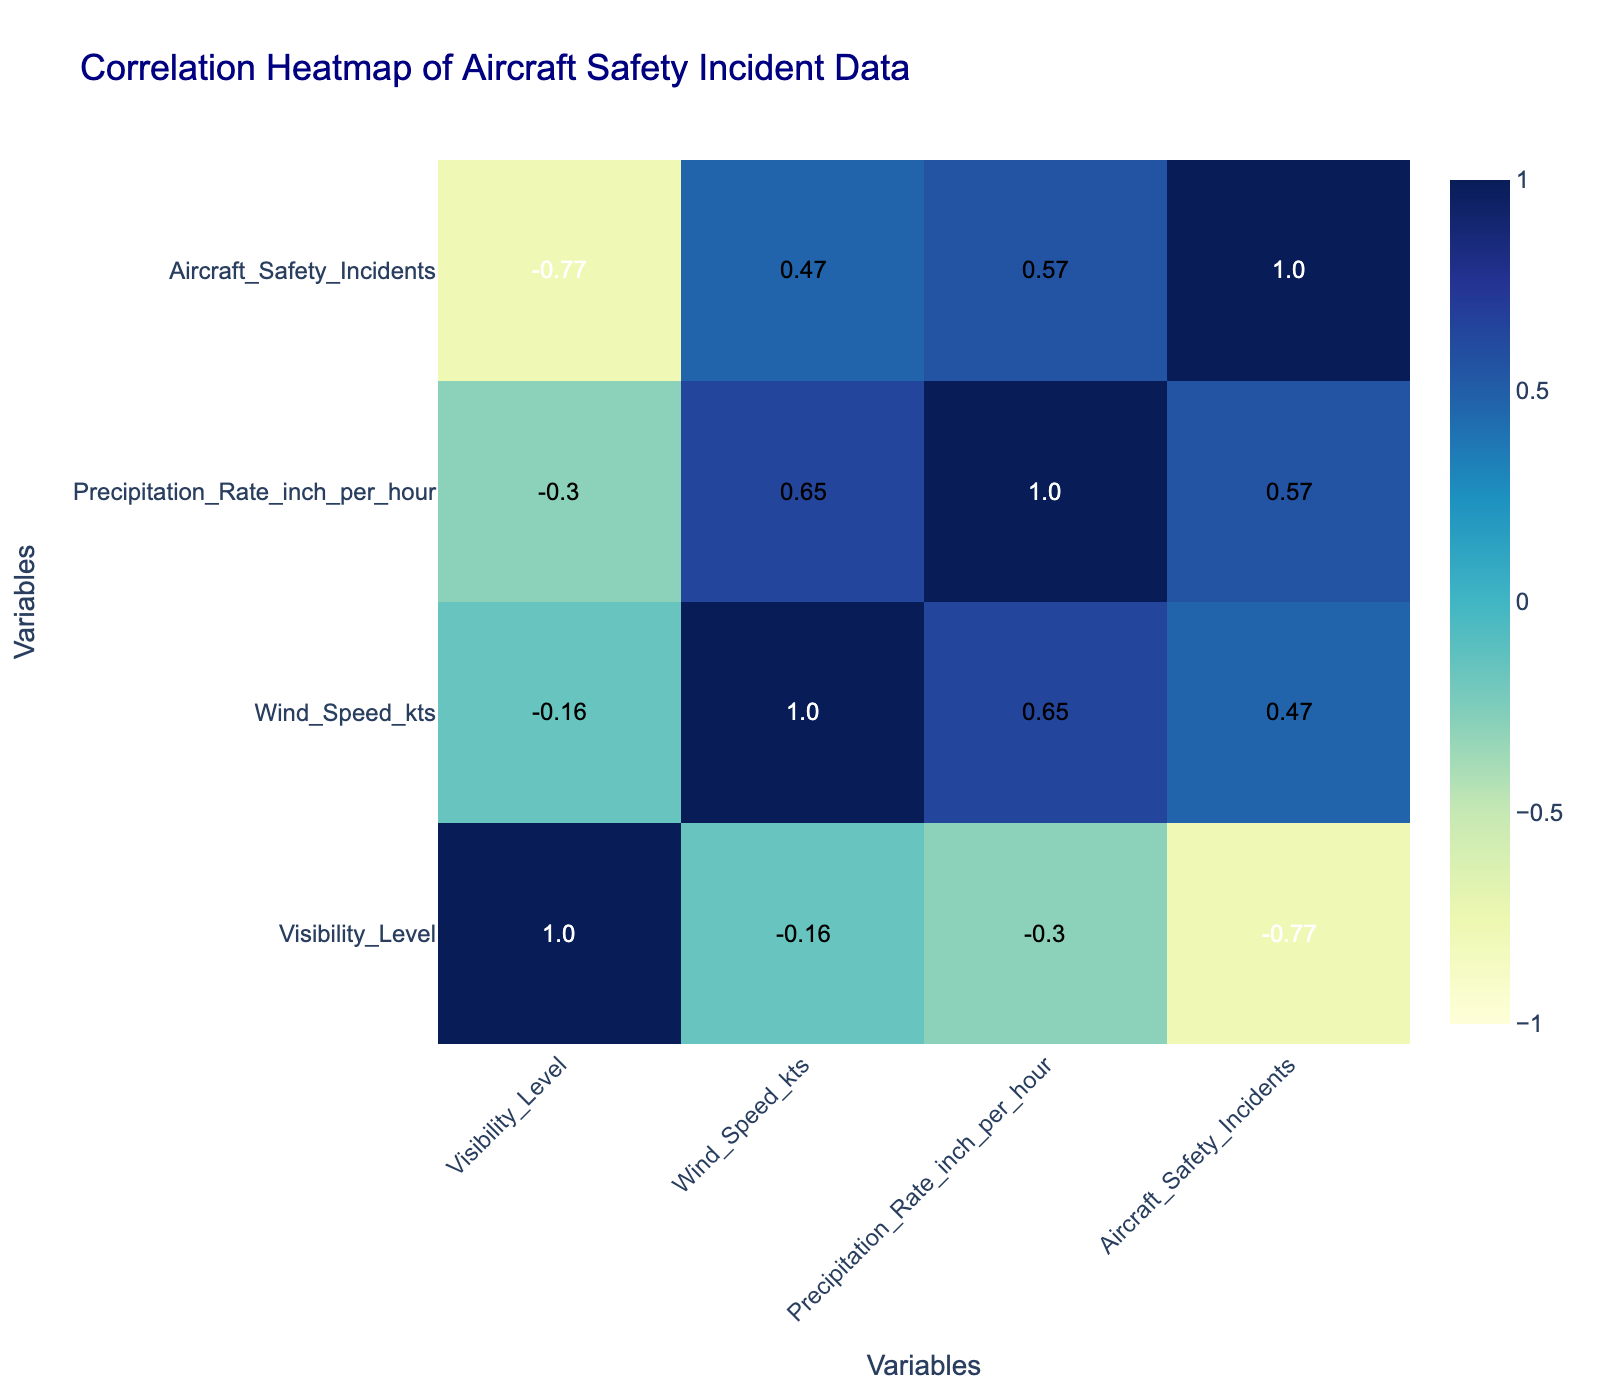What is the correlation between Wind Speed and Aircraft Safety Incidents? The correlation coefficient between Wind Speed_kts and Aircraft Safety Incidents is calculated by looking at the respective values in the correlation table. Upon inspection, the value is found to be 0.59.
Answer: 0.59 Is there a strong correlation between Visibility Level and Aircraft Safety Incidents? A strong correlation would typically be indicated by a value closer to 1 or -1. In this case, the value for Visibility Level and Aircraft Safety Incidents is -0.64, which indicates a moderate to strong negative correlation.
Answer: Yes Which weather condition is associated with the highest number of Aircraft Safety Incidents? To find the weather condition associated with the highest incidents, we refer to the data and see that "Thunderstorm" has the highest count of 40 incidents.
Answer: Thunderstorm What is the average Wind Speed for the conditions that resulted in more than 20 Aircraft Safety Incidents? First, we identify the weather conditions leading to more than 20 incidents: Fog (25), Rain (20), Heavy Rain (30), Heavy Snow (28), and Thunderstorm (40). The total Wind Speed for these conditions is (3 + 10 + 20 + 10 + 25) = 78, and the number of conditions is 5. Thus, the average is 78 / 5 = 15.6.
Answer: 15.6 Is there any relationship between Precipitation Rate and Aircraft Safety Incidents? The correlation value between Precipitation Rate_inch_per_hour and Aircraft Safety Incidents from the table is 0.49, indicating a moderate positive correlation.
Answer: Moderate positive correlation What is the highest recorded Wind Speed among the weather conditions? By examining the data provided, the highest recorded Wind Speed_kts is 25, associated with Thunderstorm conditions.
Answer: 25 Is heavy rain associated with fewer incidents than fog? Upon reviewing the number of incidents, Heavy Rain has 30 incidents, while Fog has 25 incidents. Therefore, Heavy Rain is associated with more incidents than Fog.
Answer: No What is the total count of Aircraft Safety Incidents for all weather conditions with a visibility level below 5? The weather conditions with a visibility level below 5 are Fog (25), Heavy Rain (30), Thunderstorm (40), and Heavy Snow (28). Summing these incidents gives 25 + 30 + 40 + 28 = 123.
Answer: 123 Is there a weather condition that consistently leads to high Aircraft Safety Incidents? Analyzing the conditions, Heavy Rain, Thunderstorm, and Fog show consistently high incidents. With 30, 40, and 25 incidents respectively, these conditions are recurring high-risk scenarios.
Answer: Yes 